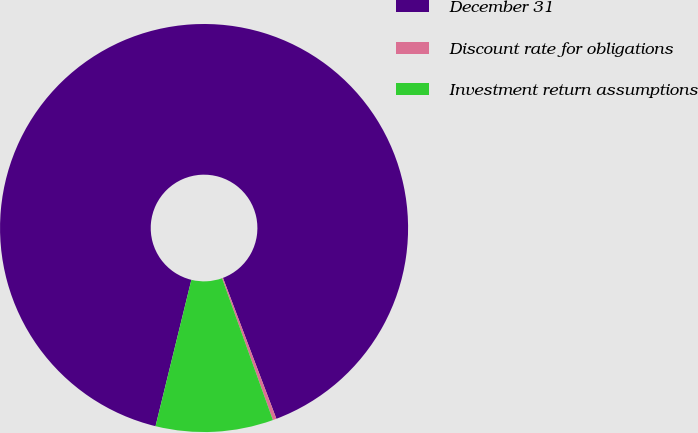Convert chart. <chart><loc_0><loc_0><loc_500><loc_500><pie_chart><fcel>December 31<fcel>Discount rate for obligations<fcel>Investment return assumptions<nl><fcel>90.4%<fcel>0.29%<fcel>9.3%<nl></chart> 